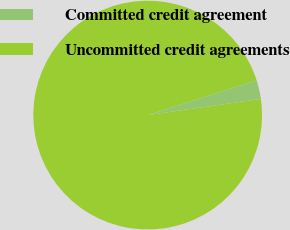Convert chart to OTSL. <chart><loc_0><loc_0><loc_500><loc_500><pie_chart><fcel>Committed credit agreement<fcel>Uncommitted credit agreements<nl><fcel>2.66%<fcel>97.34%<nl></chart> 